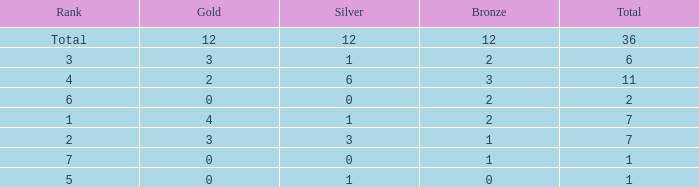What is the highest number of silver medals for a team with total less than 1? None. 